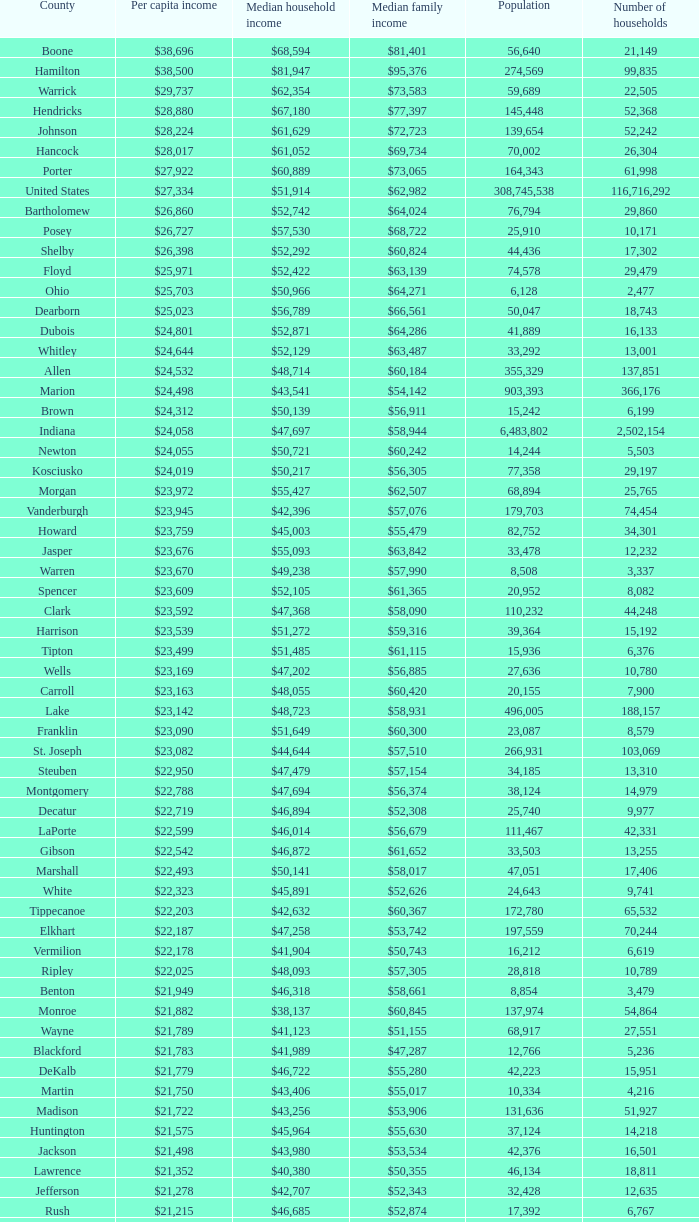What is the median family earnings when the median household earnings is $38,137? $60,845. 